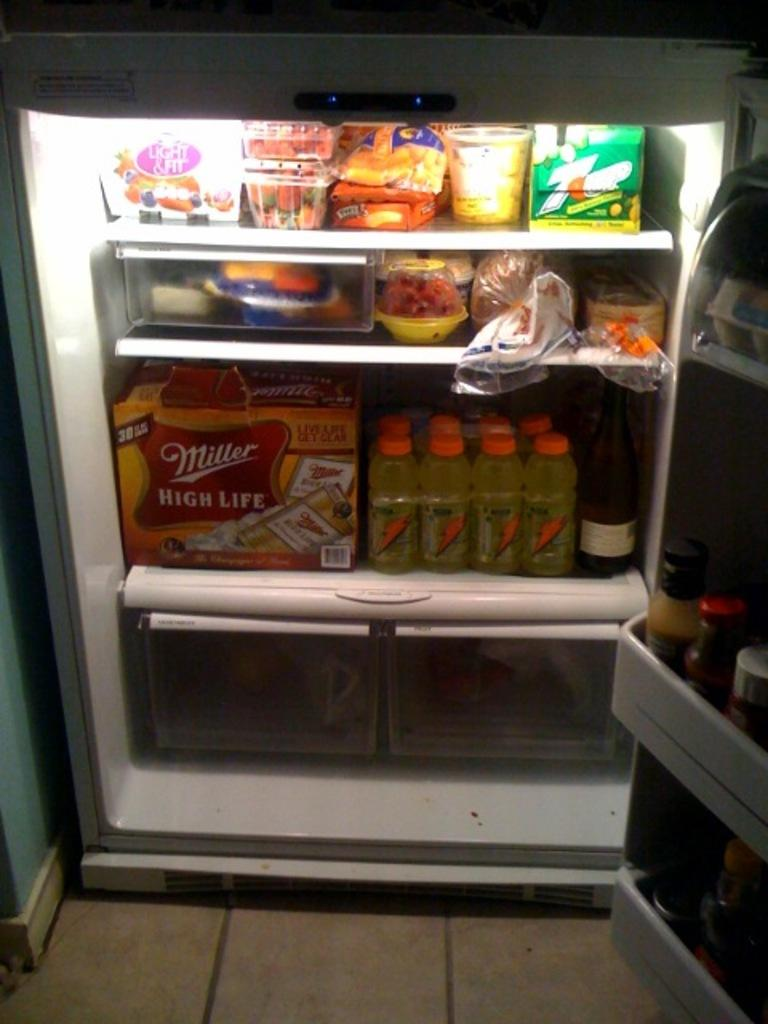<image>
Describe the image concisely. A fully stocked fridge has Gatorade and Miller High Life. 